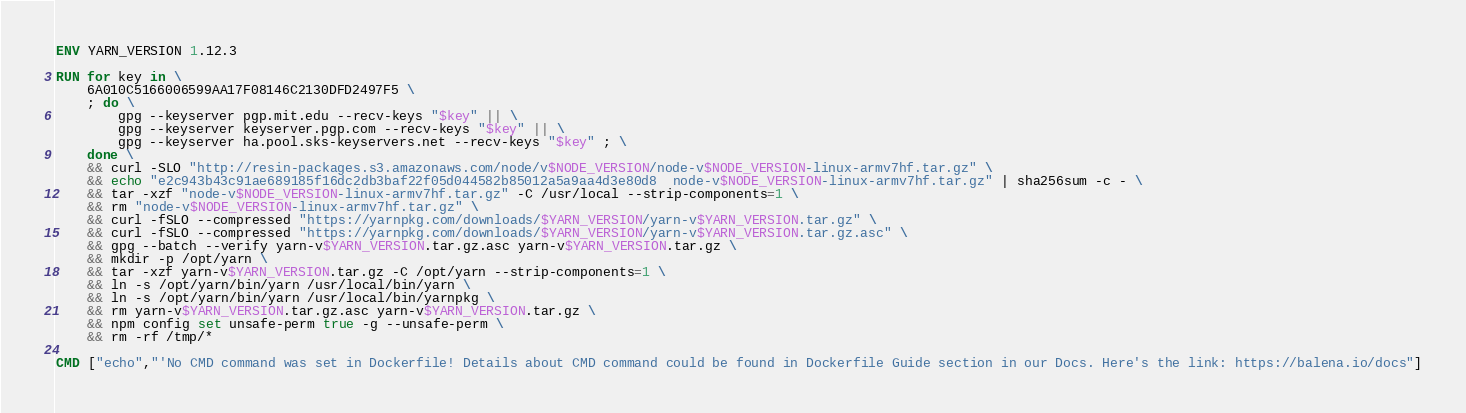Convert code to text. <code><loc_0><loc_0><loc_500><loc_500><_Dockerfile_>ENV YARN_VERSION 1.12.3

RUN for key in \
	6A010C5166006599AA17F08146C2130DFD2497F5 \
	; do \
		gpg --keyserver pgp.mit.edu --recv-keys "$key" || \
		gpg --keyserver keyserver.pgp.com --recv-keys "$key" || \
		gpg --keyserver ha.pool.sks-keyservers.net --recv-keys "$key" ; \
	done \
	&& curl -SLO "http://resin-packages.s3.amazonaws.com/node/v$NODE_VERSION/node-v$NODE_VERSION-linux-armv7hf.tar.gz" \
	&& echo "e2c943b43c91ae689185f16dc2db3baf22f05d044582b85012a5a9aa4d3e80d8  node-v$NODE_VERSION-linux-armv7hf.tar.gz" | sha256sum -c - \
	&& tar -xzf "node-v$NODE_VERSION-linux-armv7hf.tar.gz" -C /usr/local --strip-components=1 \
	&& rm "node-v$NODE_VERSION-linux-armv7hf.tar.gz" \
	&& curl -fSLO --compressed "https://yarnpkg.com/downloads/$YARN_VERSION/yarn-v$YARN_VERSION.tar.gz" \
	&& curl -fSLO --compressed "https://yarnpkg.com/downloads/$YARN_VERSION/yarn-v$YARN_VERSION.tar.gz.asc" \
	&& gpg --batch --verify yarn-v$YARN_VERSION.tar.gz.asc yarn-v$YARN_VERSION.tar.gz \
	&& mkdir -p /opt/yarn \
	&& tar -xzf yarn-v$YARN_VERSION.tar.gz -C /opt/yarn --strip-components=1 \
	&& ln -s /opt/yarn/bin/yarn /usr/local/bin/yarn \
	&& ln -s /opt/yarn/bin/yarn /usr/local/bin/yarnpkg \
	&& rm yarn-v$YARN_VERSION.tar.gz.asc yarn-v$YARN_VERSION.tar.gz \
	&& npm config set unsafe-perm true -g --unsafe-perm \
	&& rm -rf /tmp/*

CMD ["echo","'No CMD command was set in Dockerfile! Details about CMD command could be found in Dockerfile Guide section in our Docs. Here's the link: https://balena.io/docs"]</code> 